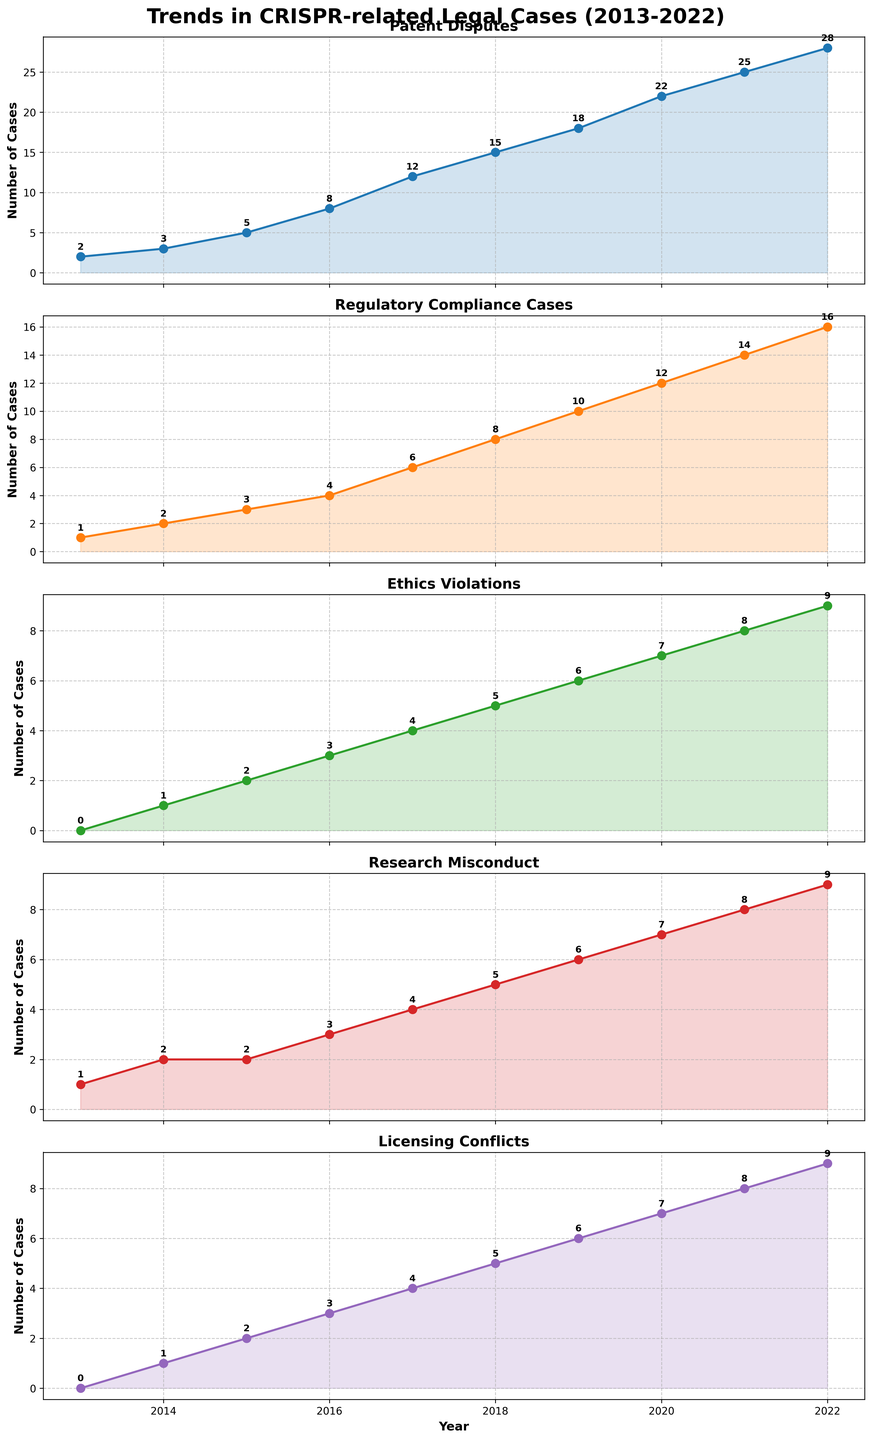What is the title of the figure? The title of the figure is located at the top center. It reads "Trends in CRISPR-related Legal Cases (2013-2022)."
Answer: Trends in CRISPR-related Legal Cases (2013-2022) How many categories of legal cases are displayed in the figure? The figure consists of separate plots for each category. By counting the number of subplots, we can see there are five categories of legal cases displayed.
Answer: Five Which category had the most significant increase from 2013 to 2022? By observing the slopes and values in each subplot, the category "Patent Disputes" shows the most significant increase. It starts at 2 cases in 2013 and ends with 28 cases in 2022.
Answer: Patent Disputes How many cases of Regulatory Compliance were there in 2017? We look at the subplot titled "Regulatory Compliance Cases" and specifically at the year 2017. It shows that there were 6 cases.
Answer: 6 Between which two consecutive years did Ethics Violations see the most considerable increase in cases? By observing the Ethics Violations plot and comparing the differences between each year's values, the biggest increase is between 2016 and 2017, rising from 3 to 4 cases.
Answer: 2016 and 2017 In which year did Licensing Conflicts reach double digits for the first time? By following the values in the Licensing Conflicts subplot, we see that it first reached 10 cases in the year 2019.
Answer: 2019 Which category had an equal number of cases in 2016 and 2017? Looking at each subplot, only the "Research Misconduct" category had the same number of cases (4) in both years, 2016 and 2017.
Answer: Research Misconduct On average, how many cases were filed per year for Research Misconduct between 2013 and 2022? First, sum the cases from 2013 to 2022 (1+2+2+3+4+5+6+7+8+9 = 47). Then, divide by the number of years (47 / 10).
Answer: 4.7 What is the sum of cases for Patent Disputes and Licensing Conflicts in 2020? We find the number of cases for each category in 2020 from their respective subplots: Patent Disputes (22) and Licensing Conflicts (7). Summing these gives us 22 + 7.
Answer: 29 